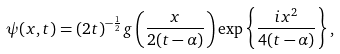Convert formula to latex. <formula><loc_0><loc_0><loc_500><loc_500>\psi ( x , t ) = ( 2 t ) ^ { - \frac { 1 } { 2 } } g \left ( \frac { x } { 2 ( t - \alpha ) } \right ) \exp \left \{ \frac { i x ^ { 2 } } { 4 ( t - \alpha ) } \right \} ,</formula> 